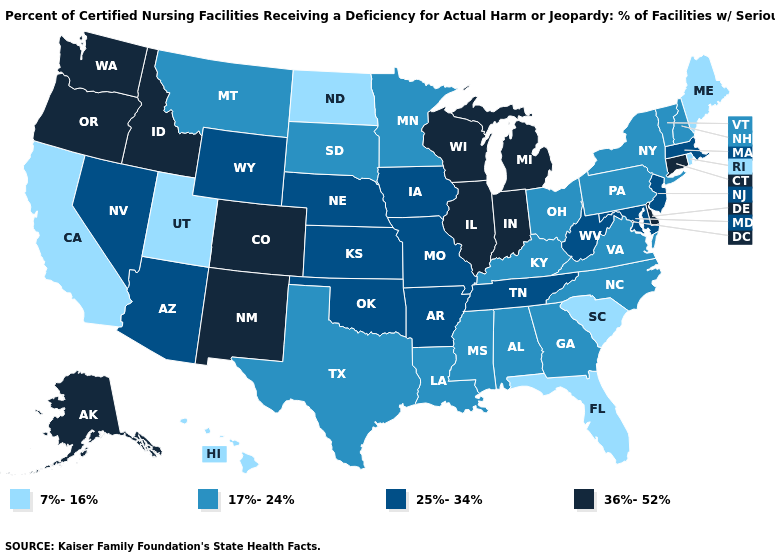Does Maryland have a lower value than North Carolina?
Short answer required. No. Does North Carolina have the highest value in the USA?
Be succinct. No. What is the highest value in the USA?
Concise answer only. 36%-52%. Name the states that have a value in the range 36%-52%?
Be succinct. Alaska, Colorado, Connecticut, Delaware, Idaho, Illinois, Indiana, Michigan, New Mexico, Oregon, Washington, Wisconsin. What is the highest value in the South ?
Write a very short answer. 36%-52%. What is the lowest value in states that border Wisconsin?
Write a very short answer. 17%-24%. Does Minnesota have the highest value in the USA?
Concise answer only. No. What is the value of Kansas?
Answer briefly. 25%-34%. Name the states that have a value in the range 36%-52%?
Give a very brief answer. Alaska, Colorado, Connecticut, Delaware, Idaho, Illinois, Indiana, Michigan, New Mexico, Oregon, Washington, Wisconsin. How many symbols are there in the legend?
Be succinct. 4. Name the states that have a value in the range 7%-16%?
Answer briefly. California, Florida, Hawaii, Maine, North Dakota, Rhode Island, South Carolina, Utah. Name the states that have a value in the range 36%-52%?
Write a very short answer. Alaska, Colorado, Connecticut, Delaware, Idaho, Illinois, Indiana, Michigan, New Mexico, Oregon, Washington, Wisconsin. How many symbols are there in the legend?
Keep it brief. 4. Which states have the lowest value in the USA?
Keep it brief. California, Florida, Hawaii, Maine, North Dakota, Rhode Island, South Carolina, Utah. What is the value of Tennessee?
Keep it brief. 25%-34%. 